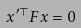<formula> <loc_0><loc_0><loc_500><loc_500>x ^ { \prime \top } F x = 0</formula> 